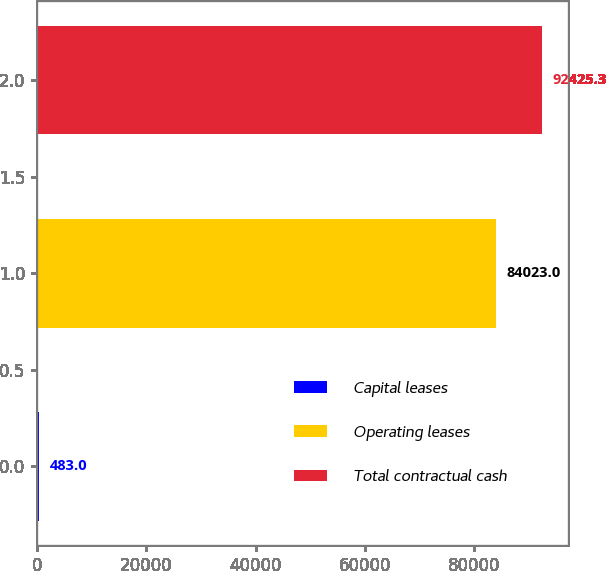Convert chart to OTSL. <chart><loc_0><loc_0><loc_500><loc_500><bar_chart><fcel>Capital leases<fcel>Operating leases<fcel>Total contractual cash<nl><fcel>483<fcel>84023<fcel>92425.3<nl></chart> 